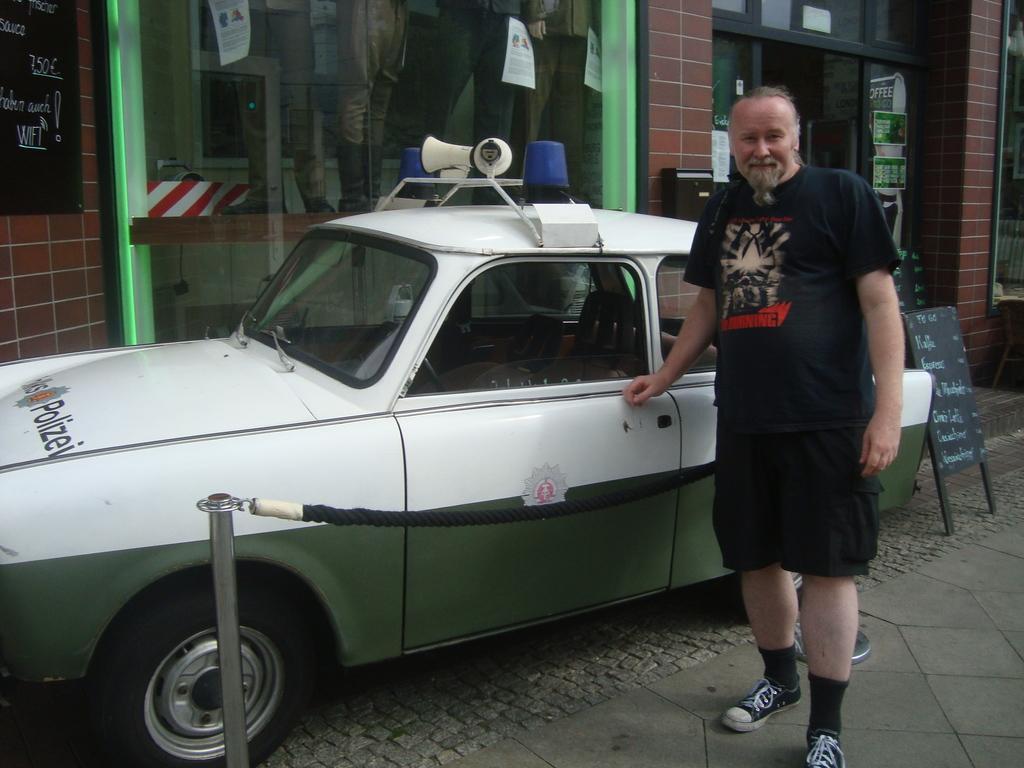Can you describe this image briefly? In this picture in the front there is a man standing and smiling. In the center there is a car which is white and green in colour. In front of the car there is a rope and there is a pole. In the background there is a building and there is a glass on the building. There is a black colour board with some text written on it and behind the glass there are statues, papers. On the right side there is a board on the ground with some text written on it which is black in colour and on the wall there are posters and the wall is red in colour. 